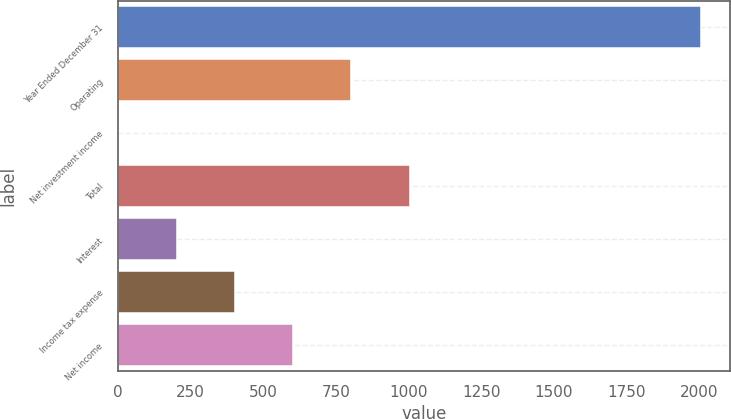Convert chart. <chart><loc_0><loc_0><loc_500><loc_500><bar_chart><fcel>Year Ended December 31<fcel>Operating<fcel>Net investment income<fcel>Total<fcel>Interest<fcel>Income tax expense<fcel>Net income<nl><fcel>2006<fcel>803<fcel>1<fcel>1003.5<fcel>201.5<fcel>402<fcel>602.5<nl></chart> 